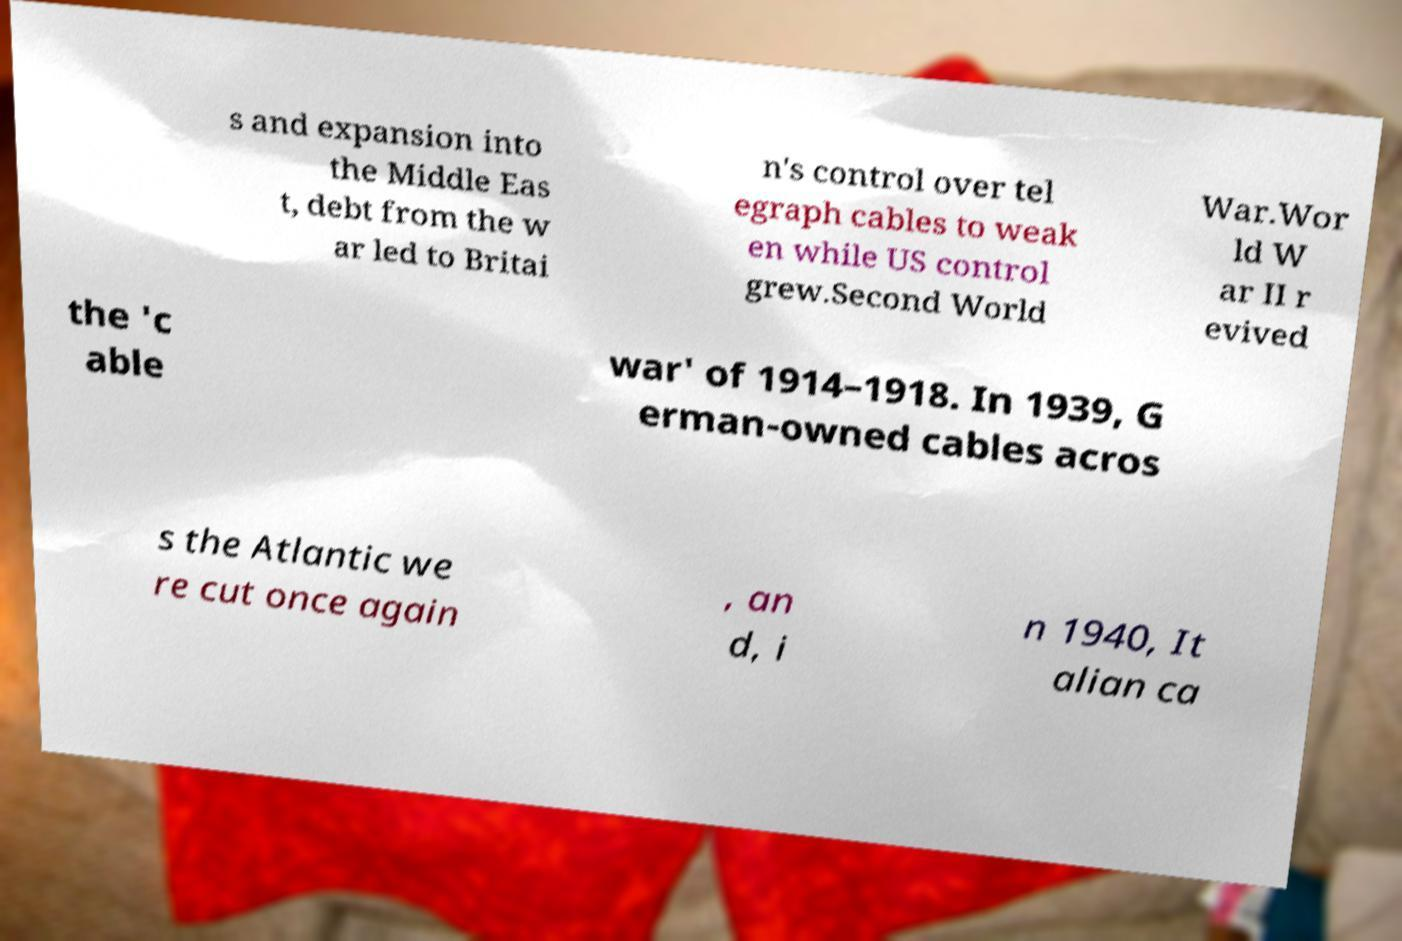I need the written content from this picture converted into text. Can you do that? s and expansion into the Middle Eas t, debt from the w ar led to Britai n's control over tel egraph cables to weak en while US control grew.Second World War.Wor ld W ar II r evived the 'c able war' of 1914–1918. In 1939, G erman-owned cables acros s the Atlantic we re cut once again , an d, i n 1940, It alian ca 